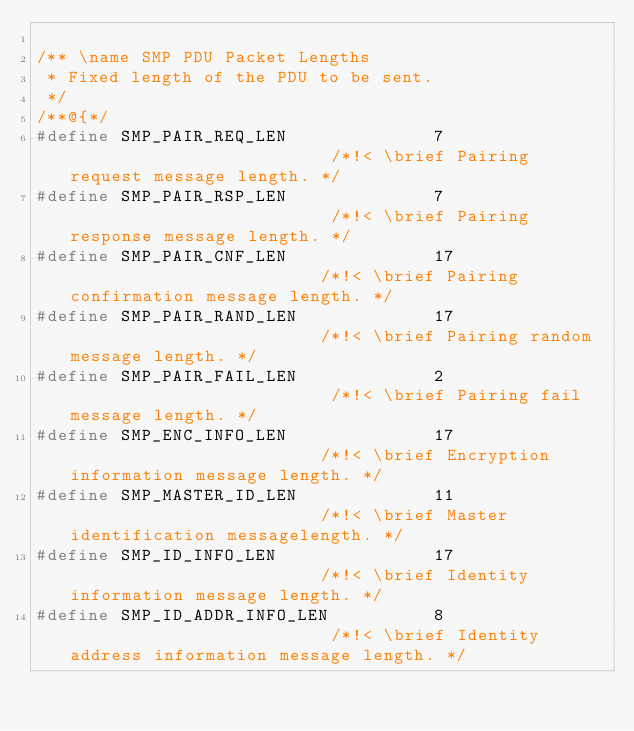Convert code to text. <code><loc_0><loc_0><loc_500><loc_500><_C_>
/** \name SMP PDU Packet Lengths
 * Fixed length of the PDU to be sent.
 */
/**@{*/
#define SMP_PAIR_REQ_LEN              7                          /*!< \brief Pairing request message length. */
#define SMP_PAIR_RSP_LEN              7                          /*!< \brief Pairing response message length. */
#define SMP_PAIR_CNF_LEN              17                         /*!< \brief Pairing confirmation message length. */
#define SMP_PAIR_RAND_LEN             17                         /*!< \brief Pairing random message length. */
#define SMP_PAIR_FAIL_LEN             2                          /*!< \brief Pairing fail message length. */
#define SMP_ENC_INFO_LEN              17                         /*!< \brief Encryption information message length. */
#define SMP_MASTER_ID_LEN             11                         /*!< \brief Master identification messagelength. */
#define SMP_ID_INFO_LEN               17                         /*!< \brief Identity information message length. */
#define SMP_ID_ADDR_INFO_LEN          8                          /*!< \brief Identity address information message length. */</code> 